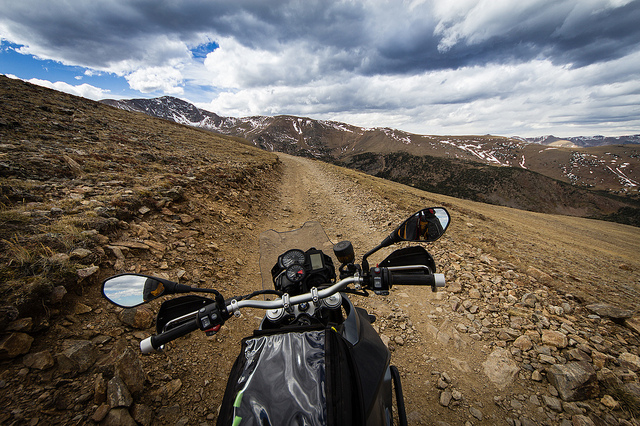Does this location look like it's frequented by travelers? The absence of any visible tire marks or footprints suggests that it's a seldom-visited area, offering a sense of solitude and untouched natural beauty. 